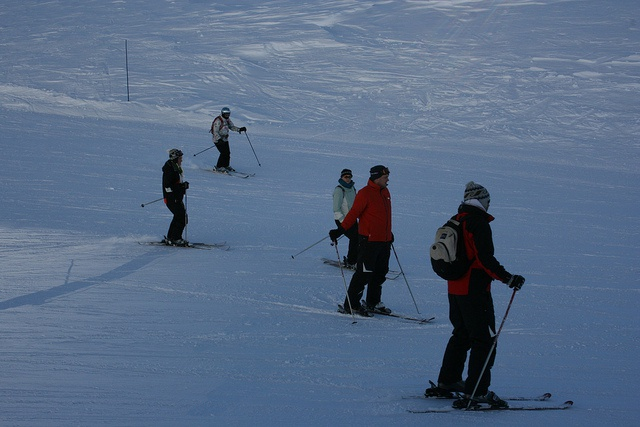Describe the objects in this image and their specific colors. I can see people in gray, black, and blue tones, people in gray, black, and maroon tones, people in gray, black, and blue tones, backpack in gray, black, purple, and darkblue tones, and people in gray, black, and blue tones in this image. 